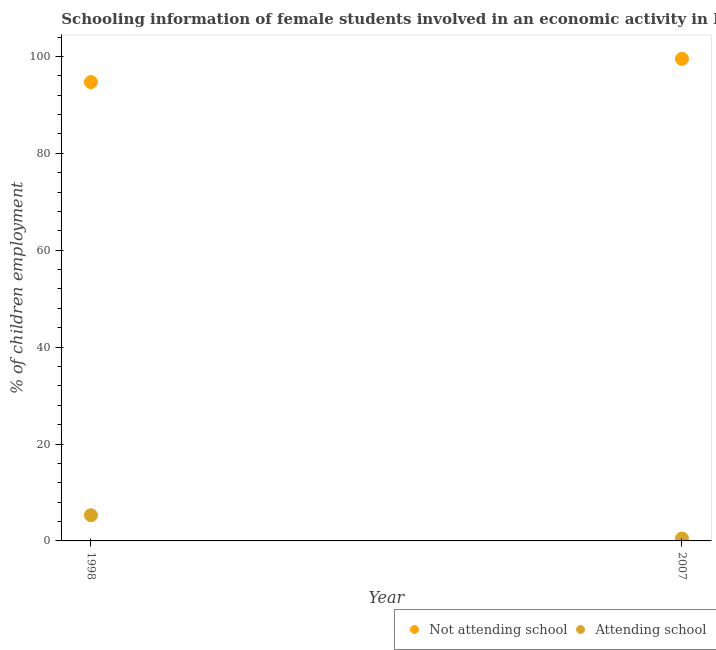What is the percentage of employed females who are not attending school in 1998?
Provide a short and direct response. 94.7. Across all years, what is the maximum percentage of employed females who are not attending school?
Provide a short and direct response. 99.5. Across all years, what is the minimum percentage of employed females who are not attending school?
Give a very brief answer. 94.7. In which year was the percentage of employed females who are not attending school minimum?
Make the answer very short. 1998. What is the total percentage of employed females who are attending school in the graph?
Your answer should be compact. 5.8. What is the difference between the percentage of employed females who are attending school in 2007 and the percentage of employed females who are not attending school in 1998?
Offer a terse response. -94.2. What is the average percentage of employed females who are not attending school per year?
Provide a succinct answer. 97.1. In the year 2007, what is the difference between the percentage of employed females who are attending school and percentage of employed females who are not attending school?
Provide a short and direct response. -99. In how many years, is the percentage of employed females who are not attending school greater than 56 %?
Give a very brief answer. 2. Is the percentage of employed females who are attending school in 1998 less than that in 2007?
Provide a succinct answer. No. In how many years, is the percentage of employed females who are attending school greater than the average percentage of employed females who are attending school taken over all years?
Offer a very short reply. 1. Does the percentage of employed females who are not attending school monotonically increase over the years?
Provide a succinct answer. Yes. Is the percentage of employed females who are not attending school strictly less than the percentage of employed females who are attending school over the years?
Make the answer very short. No. How many years are there in the graph?
Your answer should be very brief. 2. Are the values on the major ticks of Y-axis written in scientific E-notation?
Provide a succinct answer. No. Where does the legend appear in the graph?
Provide a short and direct response. Bottom right. What is the title of the graph?
Keep it short and to the point. Schooling information of female students involved in an economic activity in Kyrgyz Republic. Does "Young" appear as one of the legend labels in the graph?
Make the answer very short. No. What is the label or title of the Y-axis?
Your answer should be compact. % of children employment. What is the % of children employment of Not attending school in 1998?
Make the answer very short. 94.7. What is the % of children employment of Attending school in 1998?
Your response must be concise. 5.3. What is the % of children employment in Not attending school in 2007?
Make the answer very short. 99.5. Across all years, what is the maximum % of children employment of Not attending school?
Your answer should be very brief. 99.5. Across all years, what is the minimum % of children employment of Not attending school?
Provide a succinct answer. 94.7. Across all years, what is the minimum % of children employment of Attending school?
Give a very brief answer. 0.5. What is the total % of children employment of Not attending school in the graph?
Provide a short and direct response. 194.2. What is the total % of children employment of Attending school in the graph?
Provide a short and direct response. 5.8. What is the difference between the % of children employment in Not attending school in 1998 and that in 2007?
Your answer should be very brief. -4.8. What is the difference between the % of children employment of Not attending school in 1998 and the % of children employment of Attending school in 2007?
Make the answer very short. 94.2. What is the average % of children employment in Not attending school per year?
Offer a very short reply. 97.1. What is the average % of children employment of Attending school per year?
Give a very brief answer. 2.9. In the year 1998, what is the difference between the % of children employment in Not attending school and % of children employment in Attending school?
Provide a short and direct response. 89.4. What is the ratio of the % of children employment in Not attending school in 1998 to that in 2007?
Provide a short and direct response. 0.95. What is the difference between the highest and the second highest % of children employment of Not attending school?
Offer a very short reply. 4.8. What is the difference between the highest and the lowest % of children employment in Not attending school?
Keep it short and to the point. 4.8. 